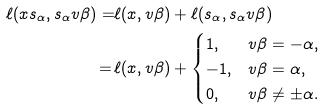Convert formula to latex. <formula><loc_0><loc_0><loc_500><loc_500>\ell ( x s _ { \alpha } , s _ { \alpha } v \beta ) = & \ell ( x , v \beta ) + \ell ( s _ { \alpha } , s _ { \alpha } v \beta ) \\ = \, & \ell ( x , v \beta ) + \begin{cases} 1 , & v \beta = - \alpha , \\ - 1 , & v \beta = \alpha , \\ 0 , & v \beta \neq \pm \alpha . \end{cases}</formula> 